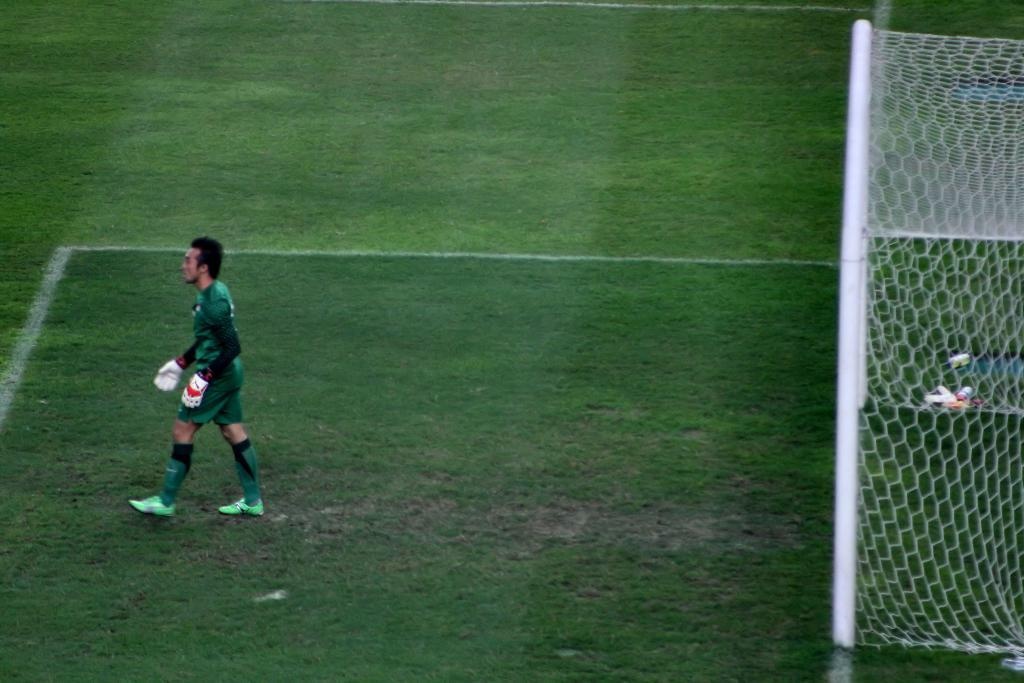What is the person in the image doing? There is a person walking in the image. What type of terrain is visible at the bottom of the image? There is grass at the bottom of the image. What can be seen on the right side of the image? There is a goal post on the right side of the image. Can you hear the person in the image laughing? There is no indication of laughter or any sound in the image, as it is a still photograph. 